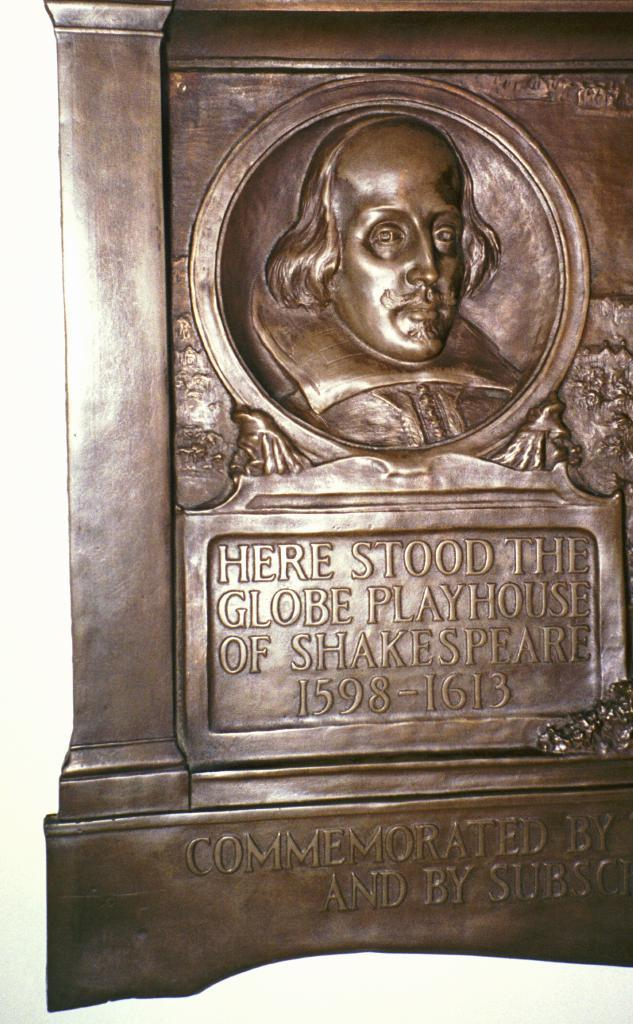What color is the main object in the image? The main object in the image is brown-colored. What is featured on the brown-colored object? Something is written on the brown-colored object. Can you describe the image at the top of the object? There is a depiction of a man's face at the top of the image. What type of sponge is used to clean the man's face in the image? There is no sponge present in the image, nor is there any indication of cleaning or maintenance. 